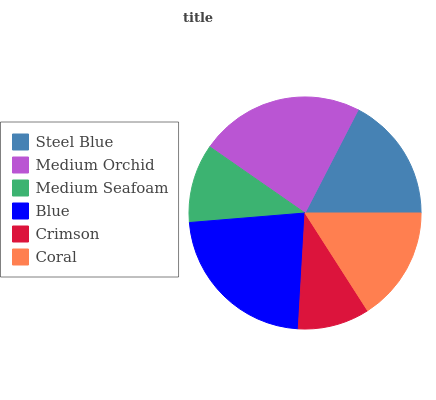Is Crimson the minimum?
Answer yes or no. Yes. Is Medium Orchid the maximum?
Answer yes or no. Yes. Is Medium Seafoam the minimum?
Answer yes or no. No. Is Medium Seafoam the maximum?
Answer yes or no. No. Is Medium Orchid greater than Medium Seafoam?
Answer yes or no. Yes. Is Medium Seafoam less than Medium Orchid?
Answer yes or no. Yes. Is Medium Seafoam greater than Medium Orchid?
Answer yes or no. No. Is Medium Orchid less than Medium Seafoam?
Answer yes or no. No. Is Steel Blue the high median?
Answer yes or no. Yes. Is Coral the low median?
Answer yes or no. Yes. Is Coral the high median?
Answer yes or no. No. Is Medium Orchid the low median?
Answer yes or no. No. 